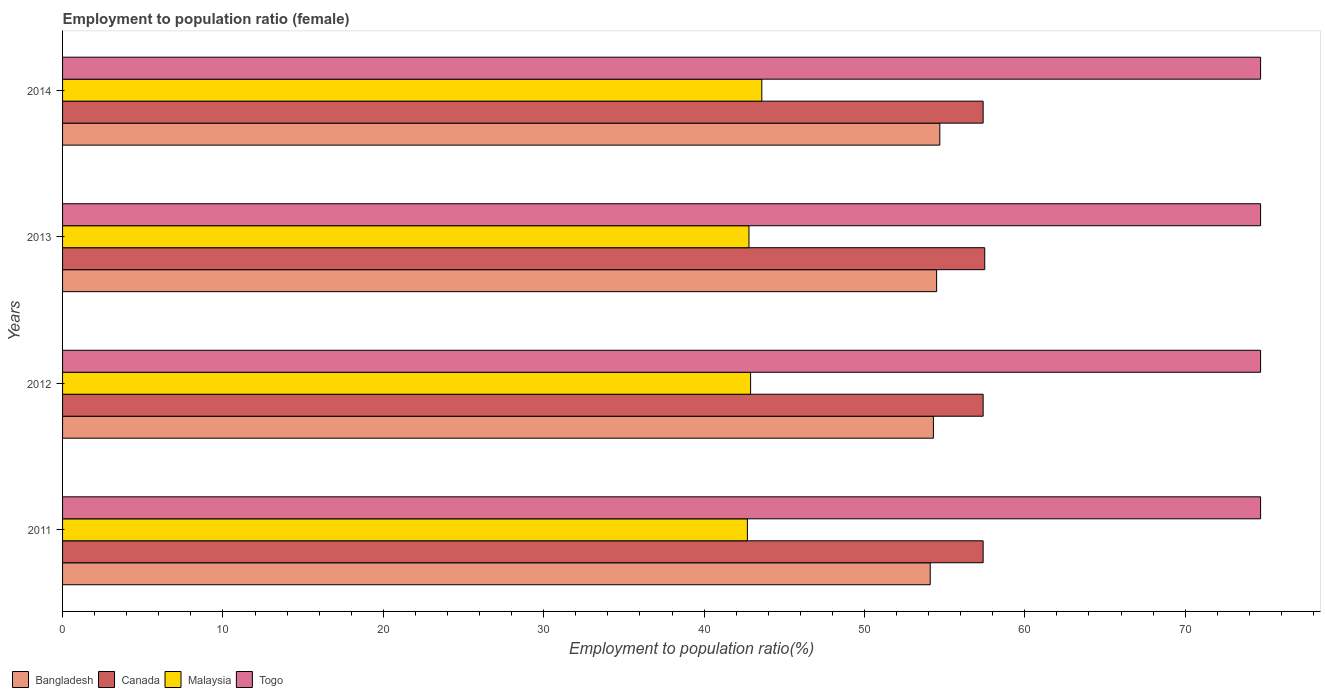How many groups of bars are there?
Your answer should be compact. 4. Are the number of bars on each tick of the Y-axis equal?
Provide a succinct answer. Yes. How many bars are there on the 4th tick from the top?
Keep it short and to the point. 4. How many bars are there on the 4th tick from the bottom?
Give a very brief answer. 4. What is the employment to population ratio in Togo in 2013?
Offer a terse response. 74.7. Across all years, what is the maximum employment to population ratio in Malaysia?
Your answer should be compact. 43.6. Across all years, what is the minimum employment to population ratio in Togo?
Provide a succinct answer. 74.7. In which year was the employment to population ratio in Togo maximum?
Your answer should be very brief. 2011. In which year was the employment to population ratio in Togo minimum?
Give a very brief answer. 2011. What is the total employment to population ratio in Canada in the graph?
Your answer should be compact. 229.7. What is the difference between the employment to population ratio in Canada in 2011 and the employment to population ratio in Togo in 2012?
Ensure brevity in your answer.  -17.3. What is the average employment to population ratio in Bangladesh per year?
Your response must be concise. 54.4. In the year 2011, what is the difference between the employment to population ratio in Canada and employment to population ratio in Malaysia?
Make the answer very short. 14.7. What is the ratio of the employment to population ratio in Bangladesh in 2011 to that in 2012?
Your response must be concise. 1. Is the employment to population ratio in Bangladesh in 2013 less than that in 2014?
Your answer should be compact. Yes. Is the difference between the employment to population ratio in Canada in 2012 and 2014 greater than the difference between the employment to population ratio in Malaysia in 2012 and 2014?
Give a very brief answer. Yes. What is the difference between the highest and the second highest employment to population ratio in Canada?
Offer a very short reply. 0.1. What is the difference between the highest and the lowest employment to population ratio in Bangladesh?
Offer a terse response. 0.6. In how many years, is the employment to population ratio in Canada greater than the average employment to population ratio in Canada taken over all years?
Give a very brief answer. 1. Is it the case that in every year, the sum of the employment to population ratio in Malaysia and employment to population ratio in Togo is greater than the sum of employment to population ratio in Bangladesh and employment to population ratio in Canada?
Ensure brevity in your answer.  Yes. What does the 1st bar from the top in 2013 represents?
Give a very brief answer. Togo. What does the 2nd bar from the bottom in 2012 represents?
Your answer should be compact. Canada. How many years are there in the graph?
Offer a terse response. 4. Are the values on the major ticks of X-axis written in scientific E-notation?
Make the answer very short. No. Does the graph contain any zero values?
Your response must be concise. No. How many legend labels are there?
Your answer should be very brief. 4. How are the legend labels stacked?
Ensure brevity in your answer.  Horizontal. What is the title of the graph?
Provide a short and direct response. Employment to population ratio (female). Does "Ireland" appear as one of the legend labels in the graph?
Provide a succinct answer. No. What is the label or title of the X-axis?
Offer a very short reply. Employment to population ratio(%). What is the label or title of the Y-axis?
Make the answer very short. Years. What is the Employment to population ratio(%) of Bangladesh in 2011?
Offer a very short reply. 54.1. What is the Employment to population ratio(%) in Canada in 2011?
Offer a very short reply. 57.4. What is the Employment to population ratio(%) of Malaysia in 2011?
Provide a succinct answer. 42.7. What is the Employment to population ratio(%) in Togo in 2011?
Offer a very short reply. 74.7. What is the Employment to population ratio(%) of Bangladesh in 2012?
Your answer should be very brief. 54.3. What is the Employment to population ratio(%) in Canada in 2012?
Keep it short and to the point. 57.4. What is the Employment to population ratio(%) in Malaysia in 2012?
Give a very brief answer. 42.9. What is the Employment to population ratio(%) in Togo in 2012?
Keep it short and to the point. 74.7. What is the Employment to population ratio(%) of Bangladesh in 2013?
Ensure brevity in your answer.  54.5. What is the Employment to population ratio(%) of Canada in 2013?
Make the answer very short. 57.5. What is the Employment to population ratio(%) of Malaysia in 2013?
Keep it short and to the point. 42.8. What is the Employment to population ratio(%) in Togo in 2013?
Give a very brief answer. 74.7. What is the Employment to population ratio(%) of Bangladesh in 2014?
Your answer should be compact. 54.7. What is the Employment to population ratio(%) in Canada in 2014?
Provide a short and direct response. 57.4. What is the Employment to population ratio(%) of Malaysia in 2014?
Offer a terse response. 43.6. What is the Employment to population ratio(%) in Togo in 2014?
Your answer should be very brief. 74.7. Across all years, what is the maximum Employment to population ratio(%) of Bangladesh?
Provide a succinct answer. 54.7. Across all years, what is the maximum Employment to population ratio(%) in Canada?
Provide a short and direct response. 57.5. Across all years, what is the maximum Employment to population ratio(%) in Malaysia?
Offer a very short reply. 43.6. Across all years, what is the maximum Employment to population ratio(%) of Togo?
Keep it short and to the point. 74.7. Across all years, what is the minimum Employment to population ratio(%) in Bangladesh?
Provide a succinct answer. 54.1. Across all years, what is the minimum Employment to population ratio(%) in Canada?
Your answer should be very brief. 57.4. Across all years, what is the minimum Employment to population ratio(%) in Malaysia?
Provide a succinct answer. 42.7. Across all years, what is the minimum Employment to population ratio(%) in Togo?
Ensure brevity in your answer.  74.7. What is the total Employment to population ratio(%) in Bangladesh in the graph?
Make the answer very short. 217.6. What is the total Employment to population ratio(%) of Canada in the graph?
Make the answer very short. 229.7. What is the total Employment to population ratio(%) of Malaysia in the graph?
Your response must be concise. 172. What is the total Employment to population ratio(%) of Togo in the graph?
Your answer should be very brief. 298.8. What is the difference between the Employment to population ratio(%) of Bangladesh in 2011 and that in 2012?
Your response must be concise. -0.2. What is the difference between the Employment to population ratio(%) of Canada in 2011 and that in 2012?
Your response must be concise. 0. What is the difference between the Employment to population ratio(%) in Canada in 2011 and that in 2013?
Provide a short and direct response. -0.1. What is the difference between the Employment to population ratio(%) of Malaysia in 2011 and that in 2013?
Provide a succinct answer. -0.1. What is the difference between the Employment to population ratio(%) of Bangladesh in 2011 and that in 2014?
Your answer should be compact. -0.6. What is the difference between the Employment to population ratio(%) of Togo in 2011 and that in 2014?
Offer a terse response. 0. What is the difference between the Employment to population ratio(%) in Bangladesh in 2012 and that in 2013?
Keep it short and to the point. -0.2. What is the difference between the Employment to population ratio(%) in Malaysia in 2012 and that in 2013?
Offer a terse response. 0.1. What is the difference between the Employment to population ratio(%) of Bangladesh in 2012 and that in 2014?
Give a very brief answer. -0.4. What is the difference between the Employment to population ratio(%) in Malaysia in 2012 and that in 2014?
Your answer should be very brief. -0.7. What is the difference between the Employment to population ratio(%) in Togo in 2012 and that in 2014?
Ensure brevity in your answer.  0. What is the difference between the Employment to population ratio(%) in Canada in 2013 and that in 2014?
Your answer should be compact. 0.1. What is the difference between the Employment to population ratio(%) in Malaysia in 2013 and that in 2014?
Make the answer very short. -0.8. What is the difference between the Employment to population ratio(%) in Togo in 2013 and that in 2014?
Provide a succinct answer. 0. What is the difference between the Employment to population ratio(%) of Bangladesh in 2011 and the Employment to population ratio(%) of Togo in 2012?
Your answer should be very brief. -20.6. What is the difference between the Employment to population ratio(%) of Canada in 2011 and the Employment to population ratio(%) of Malaysia in 2012?
Give a very brief answer. 14.5. What is the difference between the Employment to population ratio(%) in Canada in 2011 and the Employment to population ratio(%) in Togo in 2012?
Provide a short and direct response. -17.3. What is the difference between the Employment to population ratio(%) of Malaysia in 2011 and the Employment to population ratio(%) of Togo in 2012?
Keep it short and to the point. -32. What is the difference between the Employment to population ratio(%) of Bangladesh in 2011 and the Employment to population ratio(%) of Malaysia in 2013?
Offer a terse response. 11.3. What is the difference between the Employment to population ratio(%) of Bangladesh in 2011 and the Employment to population ratio(%) of Togo in 2013?
Your answer should be very brief. -20.6. What is the difference between the Employment to population ratio(%) in Canada in 2011 and the Employment to population ratio(%) in Malaysia in 2013?
Provide a short and direct response. 14.6. What is the difference between the Employment to population ratio(%) in Canada in 2011 and the Employment to population ratio(%) in Togo in 2013?
Offer a very short reply. -17.3. What is the difference between the Employment to population ratio(%) in Malaysia in 2011 and the Employment to population ratio(%) in Togo in 2013?
Your answer should be very brief. -32. What is the difference between the Employment to population ratio(%) of Bangladesh in 2011 and the Employment to population ratio(%) of Malaysia in 2014?
Provide a succinct answer. 10.5. What is the difference between the Employment to population ratio(%) in Bangladesh in 2011 and the Employment to population ratio(%) in Togo in 2014?
Give a very brief answer. -20.6. What is the difference between the Employment to population ratio(%) in Canada in 2011 and the Employment to population ratio(%) in Togo in 2014?
Give a very brief answer. -17.3. What is the difference between the Employment to population ratio(%) of Malaysia in 2011 and the Employment to population ratio(%) of Togo in 2014?
Offer a very short reply. -32. What is the difference between the Employment to population ratio(%) of Bangladesh in 2012 and the Employment to population ratio(%) of Togo in 2013?
Offer a very short reply. -20.4. What is the difference between the Employment to population ratio(%) of Canada in 2012 and the Employment to population ratio(%) of Malaysia in 2013?
Give a very brief answer. 14.6. What is the difference between the Employment to population ratio(%) of Canada in 2012 and the Employment to population ratio(%) of Togo in 2013?
Your response must be concise. -17.3. What is the difference between the Employment to population ratio(%) of Malaysia in 2012 and the Employment to population ratio(%) of Togo in 2013?
Give a very brief answer. -31.8. What is the difference between the Employment to population ratio(%) of Bangladesh in 2012 and the Employment to population ratio(%) of Togo in 2014?
Provide a succinct answer. -20.4. What is the difference between the Employment to population ratio(%) in Canada in 2012 and the Employment to population ratio(%) in Togo in 2014?
Offer a very short reply. -17.3. What is the difference between the Employment to population ratio(%) in Malaysia in 2012 and the Employment to population ratio(%) in Togo in 2014?
Offer a terse response. -31.8. What is the difference between the Employment to population ratio(%) in Bangladesh in 2013 and the Employment to population ratio(%) in Togo in 2014?
Offer a terse response. -20.2. What is the difference between the Employment to population ratio(%) in Canada in 2013 and the Employment to population ratio(%) in Togo in 2014?
Make the answer very short. -17.2. What is the difference between the Employment to population ratio(%) of Malaysia in 2013 and the Employment to population ratio(%) of Togo in 2014?
Give a very brief answer. -31.9. What is the average Employment to population ratio(%) of Bangladesh per year?
Give a very brief answer. 54.4. What is the average Employment to population ratio(%) of Canada per year?
Provide a succinct answer. 57.42. What is the average Employment to population ratio(%) in Togo per year?
Your answer should be compact. 74.7. In the year 2011, what is the difference between the Employment to population ratio(%) of Bangladesh and Employment to population ratio(%) of Canada?
Keep it short and to the point. -3.3. In the year 2011, what is the difference between the Employment to population ratio(%) in Bangladesh and Employment to population ratio(%) in Togo?
Offer a very short reply. -20.6. In the year 2011, what is the difference between the Employment to population ratio(%) in Canada and Employment to population ratio(%) in Togo?
Your answer should be compact. -17.3. In the year 2011, what is the difference between the Employment to population ratio(%) of Malaysia and Employment to population ratio(%) of Togo?
Provide a short and direct response. -32. In the year 2012, what is the difference between the Employment to population ratio(%) of Bangladesh and Employment to population ratio(%) of Malaysia?
Your answer should be compact. 11.4. In the year 2012, what is the difference between the Employment to population ratio(%) of Bangladesh and Employment to population ratio(%) of Togo?
Provide a short and direct response. -20.4. In the year 2012, what is the difference between the Employment to population ratio(%) of Canada and Employment to population ratio(%) of Malaysia?
Keep it short and to the point. 14.5. In the year 2012, what is the difference between the Employment to population ratio(%) in Canada and Employment to population ratio(%) in Togo?
Your answer should be compact. -17.3. In the year 2012, what is the difference between the Employment to population ratio(%) of Malaysia and Employment to population ratio(%) of Togo?
Your response must be concise. -31.8. In the year 2013, what is the difference between the Employment to population ratio(%) in Bangladesh and Employment to population ratio(%) in Malaysia?
Your answer should be compact. 11.7. In the year 2013, what is the difference between the Employment to population ratio(%) of Bangladesh and Employment to population ratio(%) of Togo?
Your response must be concise. -20.2. In the year 2013, what is the difference between the Employment to population ratio(%) in Canada and Employment to population ratio(%) in Malaysia?
Keep it short and to the point. 14.7. In the year 2013, what is the difference between the Employment to population ratio(%) of Canada and Employment to population ratio(%) of Togo?
Keep it short and to the point. -17.2. In the year 2013, what is the difference between the Employment to population ratio(%) of Malaysia and Employment to population ratio(%) of Togo?
Offer a terse response. -31.9. In the year 2014, what is the difference between the Employment to population ratio(%) of Bangladesh and Employment to population ratio(%) of Canada?
Offer a very short reply. -2.7. In the year 2014, what is the difference between the Employment to population ratio(%) in Bangladesh and Employment to population ratio(%) in Togo?
Offer a very short reply. -20. In the year 2014, what is the difference between the Employment to population ratio(%) in Canada and Employment to population ratio(%) in Togo?
Your answer should be compact. -17.3. In the year 2014, what is the difference between the Employment to population ratio(%) of Malaysia and Employment to population ratio(%) of Togo?
Give a very brief answer. -31.1. What is the ratio of the Employment to population ratio(%) in Bangladesh in 2011 to that in 2012?
Provide a succinct answer. 1. What is the ratio of the Employment to population ratio(%) of Togo in 2011 to that in 2012?
Keep it short and to the point. 1. What is the ratio of the Employment to population ratio(%) of Bangladesh in 2011 to that in 2013?
Your answer should be very brief. 0.99. What is the ratio of the Employment to population ratio(%) in Canada in 2011 to that in 2013?
Your response must be concise. 1. What is the ratio of the Employment to population ratio(%) in Malaysia in 2011 to that in 2013?
Provide a short and direct response. 1. What is the ratio of the Employment to population ratio(%) of Togo in 2011 to that in 2013?
Ensure brevity in your answer.  1. What is the ratio of the Employment to population ratio(%) in Canada in 2011 to that in 2014?
Make the answer very short. 1. What is the ratio of the Employment to population ratio(%) in Malaysia in 2011 to that in 2014?
Provide a short and direct response. 0.98. What is the ratio of the Employment to population ratio(%) of Canada in 2012 to that in 2014?
Your answer should be compact. 1. What is the ratio of the Employment to population ratio(%) of Malaysia in 2012 to that in 2014?
Provide a short and direct response. 0.98. What is the ratio of the Employment to population ratio(%) in Togo in 2012 to that in 2014?
Your answer should be very brief. 1. What is the ratio of the Employment to population ratio(%) in Bangladesh in 2013 to that in 2014?
Your response must be concise. 1. What is the ratio of the Employment to population ratio(%) of Malaysia in 2013 to that in 2014?
Give a very brief answer. 0.98. What is the difference between the highest and the second highest Employment to population ratio(%) of Canada?
Keep it short and to the point. 0.1. What is the difference between the highest and the second highest Employment to population ratio(%) in Malaysia?
Your response must be concise. 0.7. What is the difference between the highest and the second highest Employment to population ratio(%) in Togo?
Provide a succinct answer. 0. What is the difference between the highest and the lowest Employment to population ratio(%) of Bangladesh?
Your answer should be very brief. 0.6. What is the difference between the highest and the lowest Employment to population ratio(%) in Canada?
Provide a succinct answer. 0.1. What is the difference between the highest and the lowest Employment to population ratio(%) of Malaysia?
Make the answer very short. 0.9. What is the difference between the highest and the lowest Employment to population ratio(%) of Togo?
Provide a short and direct response. 0. 